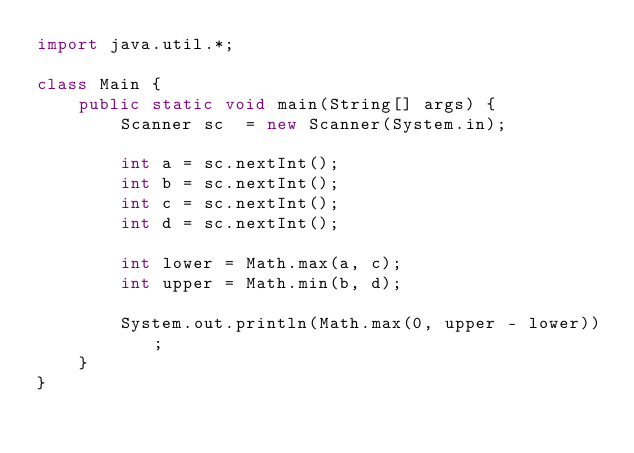Convert code to text. <code><loc_0><loc_0><loc_500><loc_500><_Java_>import java.util.*;

class Main {
    public static void main(String[] args) {
        Scanner sc  = new Scanner(System.in);
        
        int a = sc.nextInt();
        int b = sc.nextInt();
        int c = sc.nextInt();
        int d = sc.nextInt();

        int lower = Math.max(a, c);
        int upper = Math.min(b, d);

        System.out.println(Math.max(0, upper - lower));
    }
}
</code> 